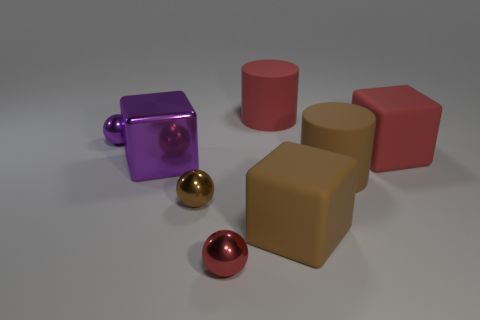Are there any small metal balls on the left side of the red metal thing?
Your answer should be compact. Yes. The big purple metallic thing has what shape?
Offer a very short reply. Cube. How many things are either big matte cylinders to the right of the brown block or small brown things?
Offer a terse response. 2. How many other things are the same color as the shiny cube?
Your response must be concise. 1. There is a shiny cube; is its color the same as the tiny object behind the red block?
Your response must be concise. Yes. Do the tiny purple object and the big brown object behind the small brown metal object have the same material?
Your response must be concise. No. What is the color of the large object behind the large rubber cube that is to the right of the big brown object behind the brown sphere?
Your answer should be very brief. Red. Do the large purple shiny object and the big red thing that is to the right of the brown matte block have the same shape?
Make the answer very short. Yes. The big object that is right of the red ball and left of the brown matte cube is what color?
Give a very brief answer. Red. Are there any red objects that have the same shape as the big purple thing?
Your answer should be very brief. Yes. 